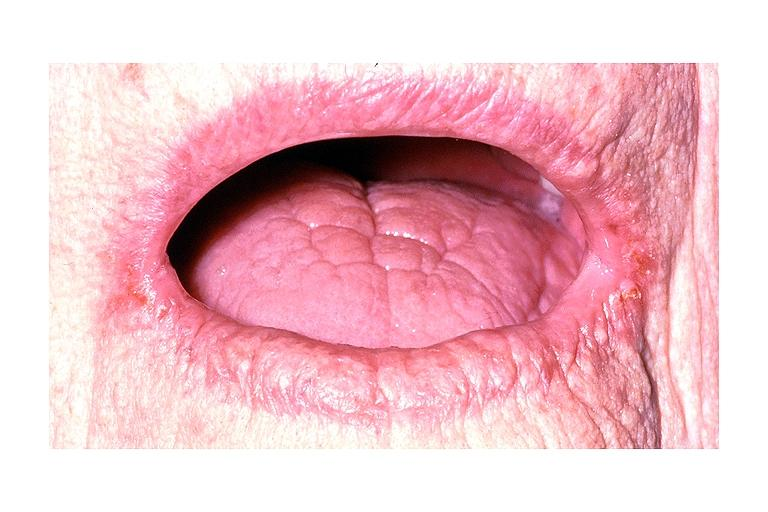does an opened peritoneal cavity cause by fibrous band strangulation show angular chelitis?
Answer the question using a single word or phrase. No 